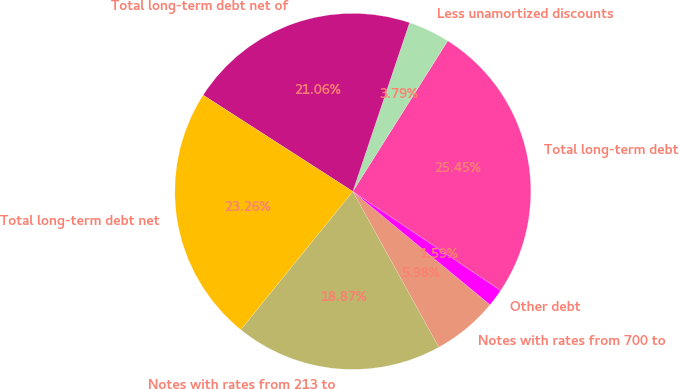Convert chart to OTSL. <chart><loc_0><loc_0><loc_500><loc_500><pie_chart><fcel>Notes with rates from 213 to<fcel>Notes with rates from 700 to<fcel>Other debt<fcel>Total long-term debt<fcel>Less unamortized discounts<fcel>Total long-term debt net of<fcel>Total long-term debt net<nl><fcel>18.87%<fcel>5.98%<fcel>1.59%<fcel>25.45%<fcel>3.79%<fcel>21.06%<fcel>23.26%<nl></chart> 